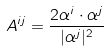Convert formula to latex. <formula><loc_0><loc_0><loc_500><loc_500>A ^ { i j } = \frac { 2 \alpha ^ { i } \cdot \alpha ^ { j } } { | \alpha ^ { j } | ^ { 2 } }</formula> 